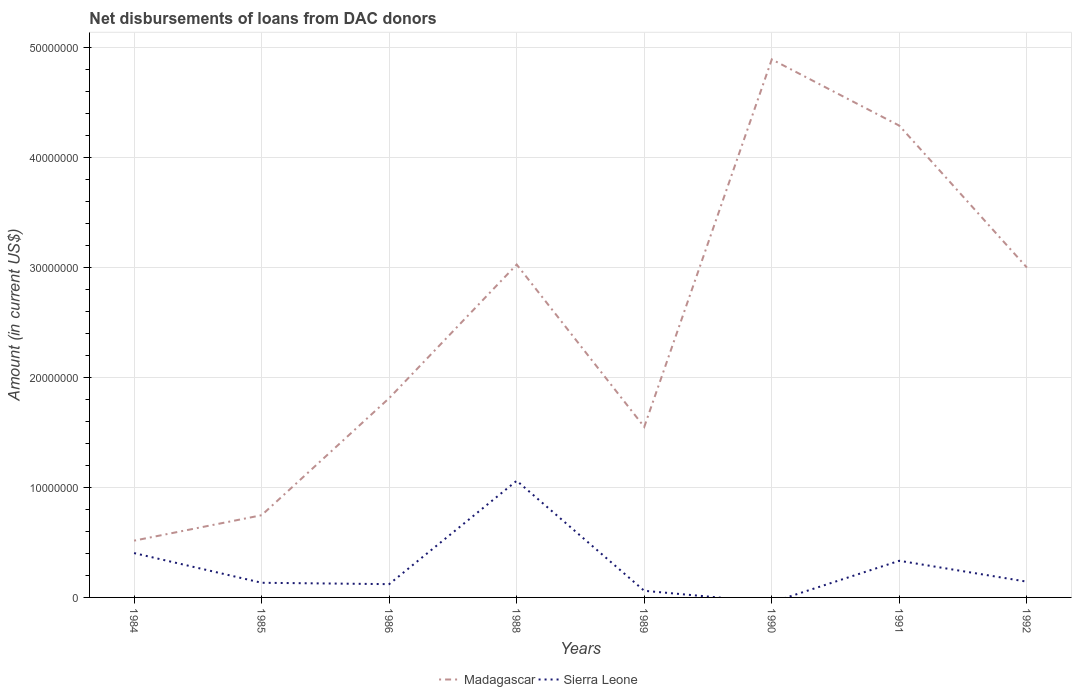How many different coloured lines are there?
Offer a terse response. 2. Is the number of lines equal to the number of legend labels?
Your answer should be very brief. No. Across all years, what is the maximum amount of loans disbursed in Madagascar?
Your response must be concise. 5.16e+06. What is the total amount of loans disbursed in Madagascar in the graph?
Give a very brief answer. -2.48e+07. What is the difference between the highest and the second highest amount of loans disbursed in Madagascar?
Provide a short and direct response. 4.37e+07. Is the amount of loans disbursed in Madagascar strictly greater than the amount of loans disbursed in Sierra Leone over the years?
Give a very brief answer. No. How many years are there in the graph?
Ensure brevity in your answer.  8. What is the difference between two consecutive major ticks on the Y-axis?
Make the answer very short. 1.00e+07. Are the values on the major ticks of Y-axis written in scientific E-notation?
Offer a terse response. No. Does the graph contain any zero values?
Offer a terse response. Yes. Where does the legend appear in the graph?
Provide a short and direct response. Bottom center. How many legend labels are there?
Your answer should be compact. 2. How are the legend labels stacked?
Offer a very short reply. Horizontal. What is the title of the graph?
Offer a terse response. Net disbursements of loans from DAC donors. Does "Denmark" appear as one of the legend labels in the graph?
Keep it short and to the point. No. What is the label or title of the X-axis?
Give a very brief answer. Years. What is the Amount (in current US$) of Madagascar in 1984?
Ensure brevity in your answer.  5.16e+06. What is the Amount (in current US$) of Sierra Leone in 1984?
Your answer should be compact. 4.03e+06. What is the Amount (in current US$) in Madagascar in 1985?
Offer a very short reply. 7.47e+06. What is the Amount (in current US$) of Sierra Leone in 1985?
Provide a short and direct response. 1.33e+06. What is the Amount (in current US$) in Madagascar in 1986?
Offer a terse response. 1.81e+07. What is the Amount (in current US$) of Sierra Leone in 1986?
Offer a very short reply. 1.21e+06. What is the Amount (in current US$) of Madagascar in 1988?
Provide a succinct answer. 3.02e+07. What is the Amount (in current US$) in Sierra Leone in 1988?
Provide a short and direct response. 1.06e+07. What is the Amount (in current US$) in Madagascar in 1989?
Your answer should be very brief. 1.55e+07. What is the Amount (in current US$) in Sierra Leone in 1989?
Provide a succinct answer. 6.03e+05. What is the Amount (in current US$) of Madagascar in 1990?
Provide a short and direct response. 4.89e+07. What is the Amount (in current US$) in Sierra Leone in 1990?
Provide a short and direct response. 0. What is the Amount (in current US$) of Madagascar in 1991?
Provide a short and direct response. 4.29e+07. What is the Amount (in current US$) in Sierra Leone in 1991?
Make the answer very short. 3.33e+06. What is the Amount (in current US$) of Madagascar in 1992?
Offer a very short reply. 3.00e+07. What is the Amount (in current US$) of Sierra Leone in 1992?
Give a very brief answer. 1.43e+06. Across all years, what is the maximum Amount (in current US$) of Madagascar?
Provide a short and direct response. 4.89e+07. Across all years, what is the maximum Amount (in current US$) in Sierra Leone?
Your answer should be very brief. 1.06e+07. Across all years, what is the minimum Amount (in current US$) of Madagascar?
Keep it short and to the point. 5.16e+06. Across all years, what is the minimum Amount (in current US$) in Sierra Leone?
Provide a short and direct response. 0. What is the total Amount (in current US$) in Madagascar in the graph?
Offer a terse response. 1.98e+08. What is the total Amount (in current US$) of Sierra Leone in the graph?
Your answer should be compact. 2.25e+07. What is the difference between the Amount (in current US$) in Madagascar in 1984 and that in 1985?
Give a very brief answer. -2.31e+06. What is the difference between the Amount (in current US$) in Sierra Leone in 1984 and that in 1985?
Your response must be concise. 2.70e+06. What is the difference between the Amount (in current US$) in Madagascar in 1984 and that in 1986?
Make the answer very short. -1.29e+07. What is the difference between the Amount (in current US$) in Sierra Leone in 1984 and that in 1986?
Keep it short and to the point. 2.82e+06. What is the difference between the Amount (in current US$) of Madagascar in 1984 and that in 1988?
Provide a succinct answer. -2.51e+07. What is the difference between the Amount (in current US$) of Sierra Leone in 1984 and that in 1988?
Make the answer very short. -6.57e+06. What is the difference between the Amount (in current US$) in Madagascar in 1984 and that in 1989?
Offer a terse response. -1.03e+07. What is the difference between the Amount (in current US$) of Sierra Leone in 1984 and that in 1989?
Make the answer very short. 3.42e+06. What is the difference between the Amount (in current US$) of Madagascar in 1984 and that in 1990?
Ensure brevity in your answer.  -4.37e+07. What is the difference between the Amount (in current US$) in Madagascar in 1984 and that in 1991?
Your answer should be compact. -3.77e+07. What is the difference between the Amount (in current US$) of Sierra Leone in 1984 and that in 1991?
Make the answer very short. 6.99e+05. What is the difference between the Amount (in current US$) in Madagascar in 1984 and that in 1992?
Provide a succinct answer. -2.48e+07. What is the difference between the Amount (in current US$) of Sierra Leone in 1984 and that in 1992?
Ensure brevity in your answer.  2.60e+06. What is the difference between the Amount (in current US$) of Madagascar in 1985 and that in 1986?
Offer a very short reply. -1.06e+07. What is the difference between the Amount (in current US$) of Sierra Leone in 1985 and that in 1986?
Your answer should be very brief. 1.25e+05. What is the difference between the Amount (in current US$) of Madagascar in 1985 and that in 1988?
Provide a succinct answer. -2.28e+07. What is the difference between the Amount (in current US$) in Sierra Leone in 1985 and that in 1988?
Your response must be concise. -9.27e+06. What is the difference between the Amount (in current US$) in Madagascar in 1985 and that in 1989?
Your answer should be very brief. -8.02e+06. What is the difference between the Amount (in current US$) in Sierra Leone in 1985 and that in 1989?
Make the answer very short. 7.28e+05. What is the difference between the Amount (in current US$) in Madagascar in 1985 and that in 1990?
Give a very brief answer. -4.14e+07. What is the difference between the Amount (in current US$) in Madagascar in 1985 and that in 1991?
Your answer should be very brief. -3.54e+07. What is the difference between the Amount (in current US$) in Sierra Leone in 1985 and that in 1991?
Provide a short and direct response. -2.00e+06. What is the difference between the Amount (in current US$) in Madagascar in 1985 and that in 1992?
Provide a succinct answer. -2.25e+07. What is the difference between the Amount (in current US$) in Madagascar in 1986 and that in 1988?
Your answer should be compact. -1.21e+07. What is the difference between the Amount (in current US$) in Sierra Leone in 1986 and that in 1988?
Make the answer very short. -9.39e+06. What is the difference between the Amount (in current US$) of Madagascar in 1986 and that in 1989?
Your response must be concise. 2.61e+06. What is the difference between the Amount (in current US$) of Sierra Leone in 1986 and that in 1989?
Offer a terse response. 6.03e+05. What is the difference between the Amount (in current US$) of Madagascar in 1986 and that in 1990?
Offer a very short reply. -3.08e+07. What is the difference between the Amount (in current US$) of Madagascar in 1986 and that in 1991?
Your response must be concise. -2.48e+07. What is the difference between the Amount (in current US$) of Sierra Leone in 1986 and that in 1991?
Give a very brief answer. -2.12e+06. What is the difference between the Amount (in current US$) of Madagascar in 1986 and that in 1992?
Provide a short and direct response. -1.19e+07. What is the difference between the Amount (in current US$) of Sierra Leone in 1986 and that in 1992?
Your response must be concise. -2.25e+05. What is the difference between the Amount (in current US$) of Madagascar in 1988 and that in 1989?
Give a very brief answer. 1.47e+07. What is the difference between the Amount (in current US$) in Sierra Leone in 1988 and that in 1989?
Your response must be concise. 1.00e+07. What is the difference between the Amount (in current US$) of Madagascar in 1988 and that in 1990?
Your response must be concise. -1.86e+07. What is the difference between the Amount (in current US$) in Madagascar in 1988 and that in 1991?
Make the answer very short. -1.26e+07. What is the difference between the Amount (in current US$) in Sierra Leone in 1988 and that in 1991?
Offer a very short reply. 7.27e+06. What is the difference between the Amount (in current US$) of Madagascar in 1988 and that in 1992?
Your answer should be very brief. 2.69e+05. What is the difference between the Amount (in current US$) in Sierra Leone in 1988 and that in 1992?
Your response must be concise. 9.17e+06. What is the difference between the Amount (in current US$) in Madagascar in 1989 and that in 1990?
Provide a short and direct response. -3.34e+07. What is the difference between the Amount (in current US$) in Madagascar in 1989 and that in 1991?
Provide a short and direct response. -2.74e+07. What is the difference between the Amount (in current US$) in Sierra Leone in 1989 and that in 1991?
Provide a succinct answer. -2.73e+06. What is the difference between the Amount (in current US$) of Madagascar in 1989 and that in 1992?
Make the answer very short. -1.45e+07. What is the difference between the Amount (in current US$) of Sierra Leone in 1989 and that in 1992?
Your answer should be compact. -8.28e+05. What is the difference between the Amount (in current US$) in Madagascar in 1990 and that in 1991?
Your response must be concise. 6.02e+06. What is the difference between the Amount (in current US$) of Madagascar in 1990 and that in 1992?
Make the answer very short. 1.89e+07. What is the difference between the Amount (in current US$) in Madagascar in 1991 and that in 1992?
Your answer should be compact. 1.29e+07. What is the difference between the Amount (in current US$) in Sierra Leone in 1991 and that in 1992?
Provide a succinct answer. 1.90e+06. What is the difference between the Amount (in current US$) in Madagascar in 1984 and the Amount (in current US$) in Sierra Leone in 1985?
Provide a succinct answer. 3.83e+06. What is the difference between the Amount (in current US$) in Madagascar in 1984 and the Amount (in current US$) in Sierra Leone in 1986?
Provide a short and direct response. 3.95e+06. What is the difference between the Amount (in current US$) in Madagascar in 1984 and the Amount (in current US$) in Sierra Leone in 1988?
Your answer should be very brief. -5.44e+06. What is the difference between the Amount (in current US$) of Madagascar in 1984 and the Amount (in current US$) of Sierra Leone in 1989?
Your answer should be compact. 4.55e+06. What is the difference between the Amount (in current US$) of Madagascar in 1984 and the Amount (in current US$) of Sierra Leone in 1991?
Give a very brief answer. 1.83e+06. What is the difference between the Amount (in current US$) of Madagascar in 1984 and the Amount (in current US$) of Sierra Leone in 1992?
Your response must be concise. 3.73e+06. What is the difference between the Amount (in current US$) in Madagascar in 1985 and the Amount (in current US$) in Sierra Leone in 1986?
Keep it short and to the point. 6.26e+06. What is the difference between the Amount (in current US$) in Madagascar in 1985 and the Amount (in current US$) in Sierra Leone in 1988?
Make the answer very short. -3.13e+06. What is the difference between the Amount (in current US$) in Madagascar in 1985 and the Amount (in current US$) in Sierra Leone in 1989?
Offer a very short reply. 6.87e+06. What is the difference between the Amount (in current US$) of Madagascar in 1985 and the Amount (in current US$) of Sierra Leone in 1991?
Provide a short and direct response. 4.14e+06. What is the difference between the Amount (in current US$) in Madagascar in 1985 and the Amount (in current US$) in Sierra Leone in 1992?
Ensure brevity in your answer.  6.04e+06. What is the difference between the Amount (in current US$) of Madagascar in 1986 and the Amount (in current US$) of Sierra Leone in 1988?
Offer a terse response. 7.50e+06. What is the difference between the Amount (in current US$) of Madagascar in 1986 and the Amount (in current US$) of Sierra Leone in 1989?
Keep it short and to the point. 1.75e+07. What is the difference between the Amount (in current US$) in Madagascar in 1986 and the Amount (in current US$) in Sierra Leone in 1991?
Your answer should be very brief. 1.48e+07. What is the difference between the Amount (in current US$) of Madagascar in 1986 and the Amount (in current US$) of Sierra Leone in 1992?
Your answer should be compact. 1.67e+07. What is the difference between the Amount (in current US$) of Madagascar in 1988 and the Amount (in current US$) of Sierra Leone in 1989?
Keep it short and to the point. 2.96e+07. What is the difference between the Amount (in current US$) of Madagascar in 1988 and the Amount (in current US$) of Sierra Leone in 1991?
Your answer should be compact. 2.69e+07. What is the difference between the Amount (in current US$) of Madagascar in 1988 and the Amount (in current US$) of Sierra Leone in 1992?
Ensure brevity in your answer.  2.88e+07. What is the difference between the Amount (in current US$) of Madagascar in 1989 and the Amount (in current US$) of Sierra Leone in 1991?
Your answer should be very brief. 1.22e+07. What is the difference between the Amount (in current US$) of Madagascar in 1989 and the Amount (in current US$) of Sierra Leone in 1992?
Provide a succinct answer. 1.41e+07. What is the difference between the Amount (in current US$) in Madagascar in 1990 and the Amount (in current US$) in Sierra Leone in 1991?
Offer a very short reply. 4.55e+07. What is the difference between the Amount (in current US$) in Madagascar in 1990 and the Amount (in current US$) in Sierra Leone in 1992?
Your response must be concise. 4.74e+07. What is the difference between the Amount (in current US$) of Madagascar in 1991 and the Amount (in current US$) of Sierra Leone in 1992?
Your answer should be very brief. 4.14e+07. What is the average Amount (in current US$) of Madagascar per year?
Provide a short and direct response. 2.48e+07. What is the average Amount (in current US$) of Sierra Leone per year?
Offer a terse response. 2.82e+06. In the year 1984, what is the difference between the Amount (in current US$) in Madagascar and Amount (in current US$) in Sierra Leone?
Keep it short and to the point. 1.13e+06. In the year 1985, what is the difference between the Amount (in current US$) of Madagascar and Amount (in current US$) of Sierra Leone?
Your answer should be very brief. 6.14e+06. In the year 1986, what is the difference between the Amount (in current US$) in Madagascar and Amount (in current US$) in Sierra Leone?
Your answer should be very brief. 1.69e+07. In the year 1988, what is the difference between the Amount (in current US$) in Madagascar and Amount (in current US$) in Sierra Leone?
Keep it short and to the point. 1.96e+07. In the year 1989, what is the difference between the Amount (in current US$) in Madagascar and Amount (in current US$) in Sierra Leone?
Make the answer very short. 1.49e+07. In the year 1991, what is the difference between the Amount (in current US$) in Madagascar and Amount (in current US$) in Sierra Leone?
Your answer should be very brief. 3.95e+07. In the year 1992, what is the difference between the Amount (in current US$) of Madagascar and Amount (in current US$) of Sierra Leone?
Offer a very short reply. 2.85e+07. What is the ratio of the Amount (in current US$) of Madagascar in 1984 to that in 1985?
Keep it short and to the point. 0.69. What is the ratio of the Amount (in current US$) in Sierra Leone in 1984 to that in 1985?
Your response must be concise. 3.03. What is the ratio of the Amount (in current US$) in Madagascar in 1984 to that in 1986?
Keep it short and to the point. 0.28. What is the ratio of the Amount (in current US$) of Sierra Leone in 1984 to that in 1986?
Provide a short and direct response. 3.34. What is the ratio of the Amount (in current US$) of Madagascar in 1984 to that in 1988?
Keep it short and to the point. 0.17. What is the ratio of the Amount (in current US$) in Sierra Leone in 1984 to that in 1988?
Give a very brief answer. 0.38. What is the ratio of the Amount (in current US$) of Madagascar in 1984 to that in 1989?
Offer a very short reply. 0.33. What is the ratio of the Amount (in current US$) in Sierra Leone in 1984 to that in 1989?
Provide a succinct answer. 6.68. What is the ratio of the Amount (in current US$) in Madagascar in 1984 to that in 1990?
Offer a terse response. 0.11. What is the ratio of the Amount (in current US$) in Madagascar in 1984 to that in 1991?
Offer a very short reply. 0.12. What is the ratio of the Amount (in current US$) of Sierra Leone in 1984 to that in 1991?
Provide a short and direct response. 1.21. What is the ratio of the Amount (in current US$) in Madagascar in 1984 to that in 1992?
Offer a very short reply. 0.17. What is the ratio of the Amount (in current US$) in Sierra Leone in 1984 to that in 1992?
Provide a short and direct response. 2.81. What is the ratio of the Amount (in current US$) of Madagascar in 1985 to that in 1986?
Your response must be concise. 0.41. What is the ratio of the Amount (in current US$) of Sierra Leone in 1985 to that in 1986?
Your answer should be compact. 1.1. What is the ratio of the Amount (in current US$) of Madagascar in 1985 to that in 1988?
Ensure brevity in your answer.  0.25. What is the ratio of the Amount (in current US$) in Sierra Leone in 1985 to that in 1988?
Your answer should be very brief. 0.13. What is the ratio of the Amount (in current US$) of Madagascar in 1985 to that in 1989?
Your response must be concise. 0.48. What is the ratio of the Amount (in current US$) in Sierra Leone in 1985 to that in 1989?
Your answer should be very brief. 2.21. What is the ratio of the Amount (in current US$) in Madagascar in 1985 to that in 1990?
Offer a very short reply. 0.15. What is the ratio of the Amount (in current US$) of Madagascar in 1985 to that in 1991?
Your answer should be very brief. 0.17. What is the ratio of the Amount (in current US$) in Sierra Leone in 1985 to that in 1991?
Make the answer very short. 0.4. What is the ratio of the Amount (in current US$) in Madagascar in 1985 to that in 1992?
Ensure brevity in your answer.  0.25. What is the ratio of the Amount (in current US$) of Sierra Leone in 1985 to that in 1992?
Ensure brevity in your answer.  0.93. What is the ratio of the Amount (in current US$) in Madagascar in 1986 to that in 1988?
Give a very brief answer. 0.6. What is the ratio of the Amount (in current US$) of Sierra Leone in 1986 to that in 1988?
Your response must be concise. 0.11. What is the ratio of the Amount (in current US$) of Madagascar in 1986 to that in 1989?
Give a very brief answer. 1.17. What is the ratio of the Amount (in current US$) of Madagascar in 1986 to that in 1990?
Your answer should be very brief. 0.37. What is the ratio of the Amount (in current US$) in Madagascar in 1986 to that in 1991?
Make the answer very short. 0.42. What is the ratio of the Amount (in current US$) in Sierra Leone in 1986 to that in 1991?
Your response must be concise. 0.36. What is the ratio of the Amount (in current US$) in Madagascar in 1986 to that in 1992?
Your response must be concise. 0.6. What is the ratio of the Amount (in current US$) of Sierra Leone in 1986 to that in 1992?
Offer a very short reply. 0.84. What is the ratio of the Amount (in current US$) in Madagascar in 1988 to that in 1989?
Your response must be concise. 1.95. What is the ratio of the Amount (in current US$) in Sierra Leone in 1988 to that in 1989?
Offer a terse response. 17.58. What is the ratio of the Amount (in current US$) of Madagascar in 1988 to that in 1990?
Your answer should be compact. 0.62. What is the ratio of the Amount (in current US$) in Madagascar in 1988 to that in 1991?
Your answer should be compact. 0.71. What is the ratio of the Amount (in current US$) of Sierra Leone in 1988 to that in 1991?
Make the answer very short. 3.18. What is the ratio of the Amount (in current US$) of Madagascar in 1988 to that in 1992?
Provide a succinct answer. 1.01. What is the ratio of the Amount (in current US$) in Sierra Leone in 1988 to that in 1992?
Ensure brevity in your answer.  7.41. What is the ratio of the Amount (in current US$) of Madagascar in 1989 to that in 1990?
Give a very brief answer. 0.32. What is the ratio of the Amount (in current US$) in Madagascar in 1989 to that in 1991?
Offer a terse response. 0.36. What is the ratio of the Amount (in current US$) in Sierra Leone in 1989 to that in 1991?
Offer a terse response. 0.18. What is the ratio of the Amount (in current US$) in Madagascar in 1989 to that in 1992?
Offer a terse response. 0.52. What is the ratio of the Amount (in current US$) in Sierra Leone in 1989 to that in 1992?
Keep it short and to the point. 0.42. What is the ratio of the Amount (in current US$) of Madagascar in 1990 to that in 1991?
Keep it short and to the point. 1.14. What is the ratio of the Amount (in current US$) of Madagascar in 1990 to that in 1992?
Make the answer very short. 1.63. What is the ratio of the Amount (in current US$) of Madagascar in 1991 to that in 1992?
Your response must be concise. 1.43. What is the ratio of the Amount (in current US$) in Sierra Leone in 1991 to that in 1992?
Make the answer very short. 2.33. What is the difference between the highest and the second highest Amount (in current US$) of Madagascar?
Your answer should be very brief. 6.02e+06. What is the difference between the highest and the second highest Amount (in current US$) of Sierra Leone?
Your answer should be very brief. 6.57e+06. What is the difference between the highest and the lowest Amount (in current US$) in Madagascar?
Your response must be concise. 4.37e+07. What is the difference between the highest and the lowest Amount (in current US$) in Sierra Leone?
Keep it short and to the point. 1.06e+07. 